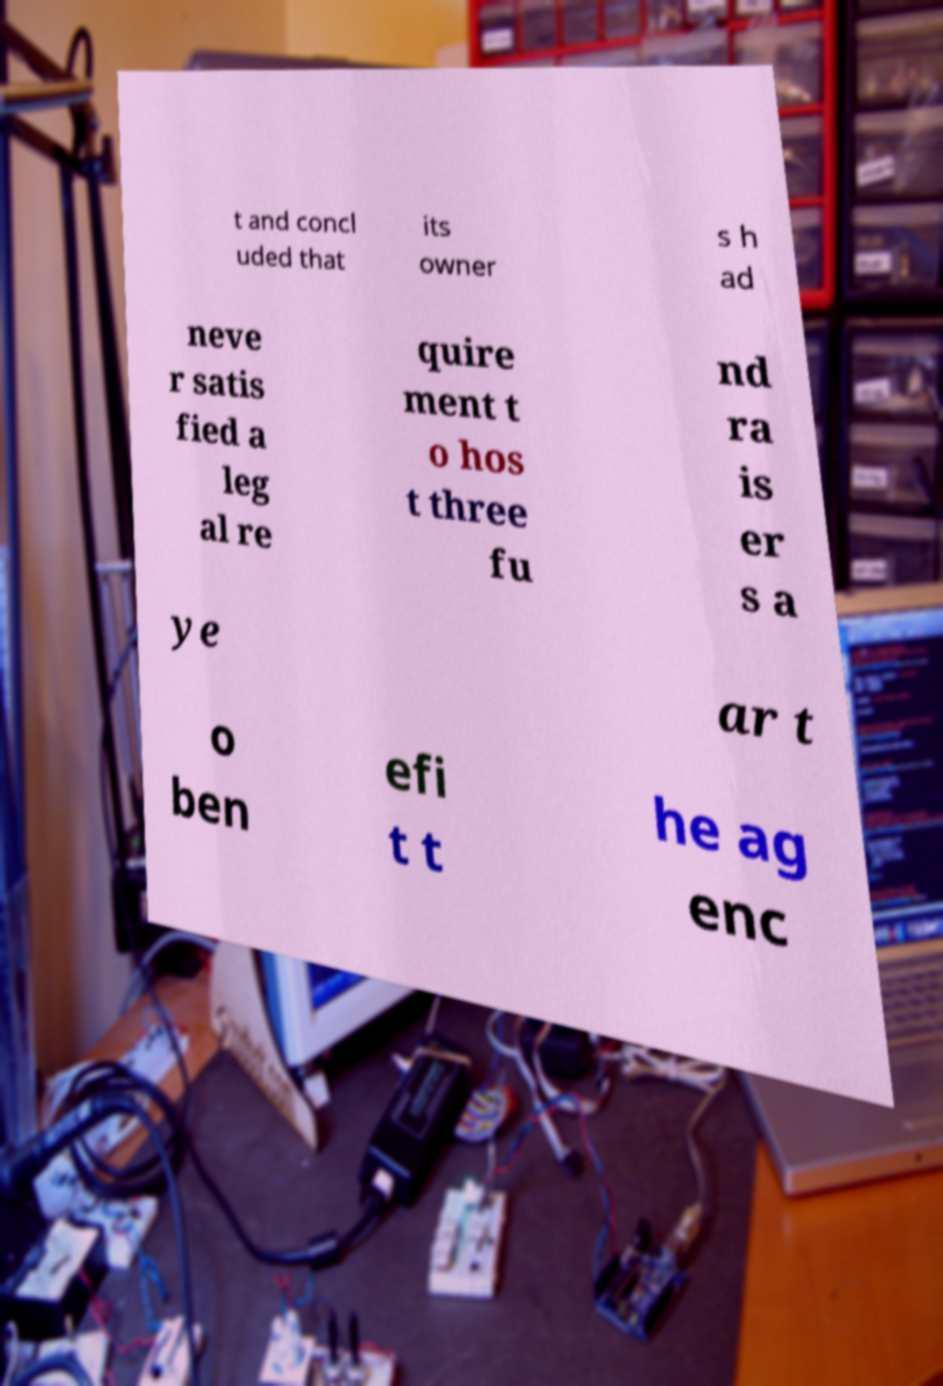Can you read and provide the text displayed in the image?This photo seems to have some interesting text. Can you extract and type it out for me? t and concl uded that its owner s h ad neve r satis fied a leg al re quire ment t o hos t three fu nd ra is er s a ye ar t o ben efi t t he ag enc 